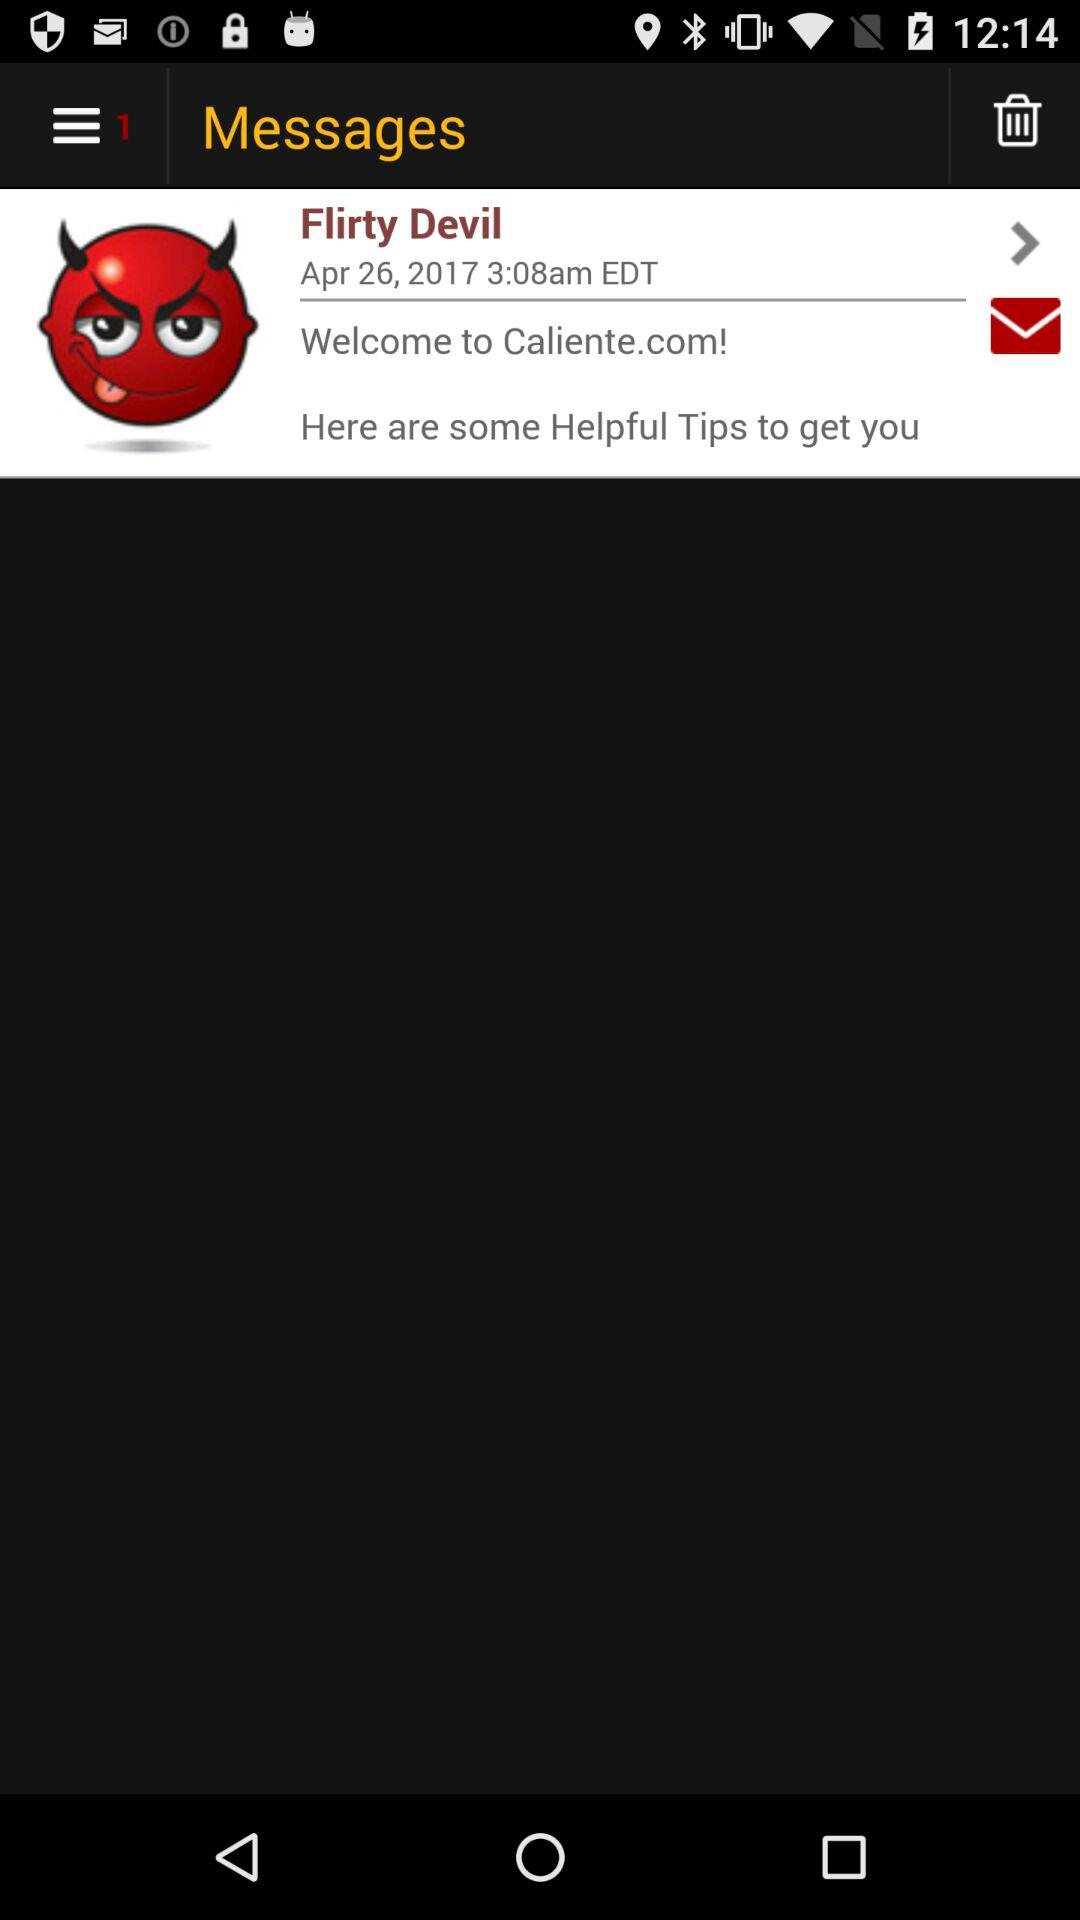What is the name of the message sender? The name of the message sender is Flirty Devil. 